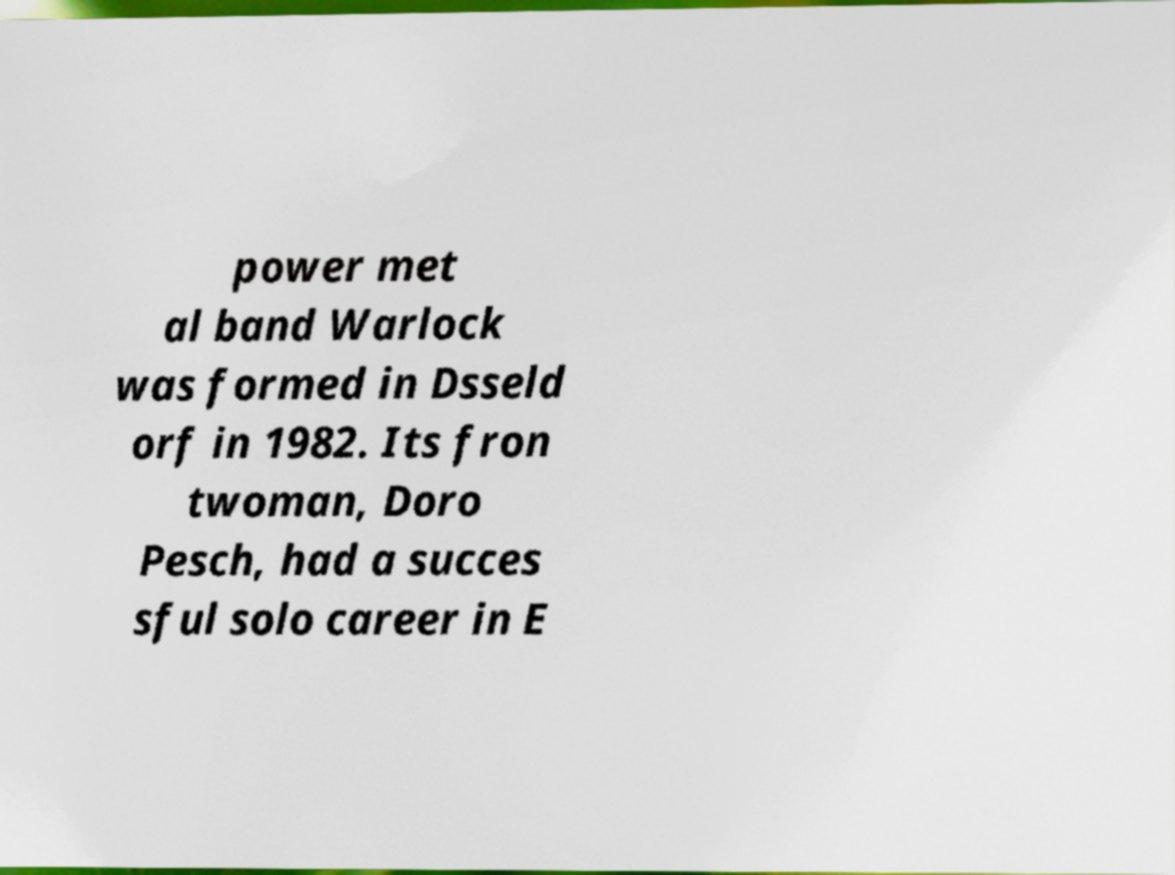For documentation purposes, I need the text within this image transcribed. Could you provide that? power met al band Warlock was formed in Dsseld orf in 1982. Its fron twoman, Doro Pesch, had a succes sful solo career in E 